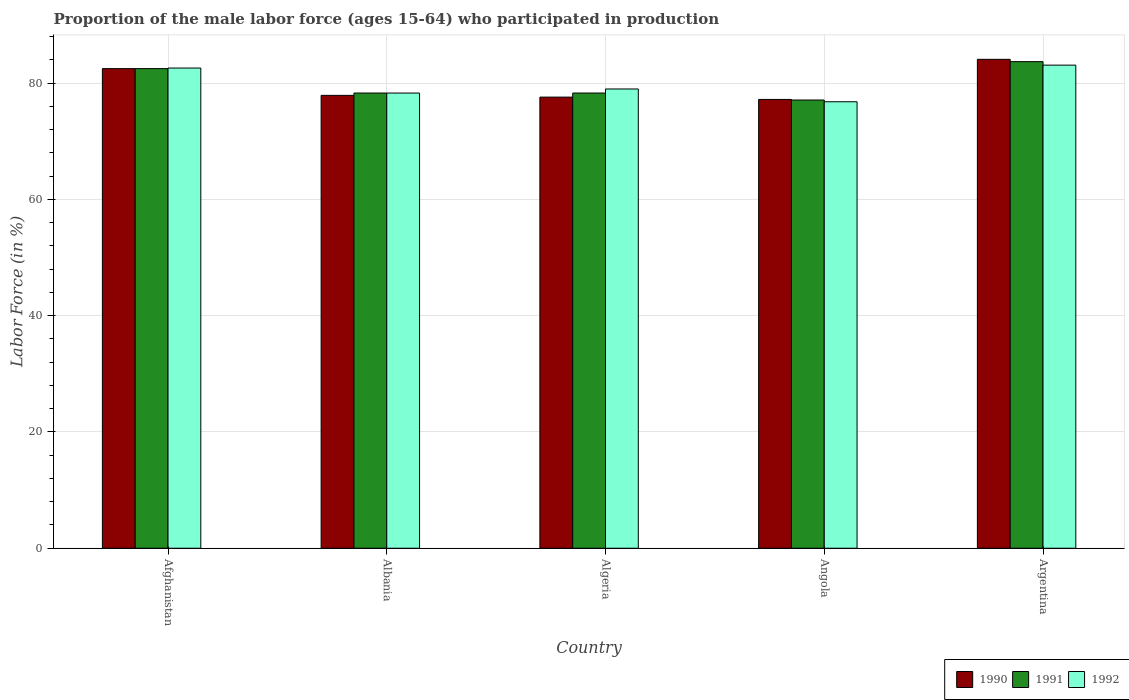How many different coloured bars are there?
Make the answer very short. 3. Are the number of bars per tick equal to the number of legend labels?
Provide a succinct answer. Yes. How many bars are there on the 5th tick from the left?
Your response must be concise. 3. What is the label of the 2nd group of bars from the left?
Provide a short and direct response. Albania. What is the proportion of the male labor force who participated in production in 1992 in Afghanistan?
Your response must be concise. 82.6. Across all countries, what is the maximum proportion of the male labor force who participated in production in 1991?
Offer a very short reply. 83.7. Across all countries, what is the minimum proportion of the male labor force who participated in production in 1990?
Offer a very short reply. 77.2. In which country was the proportion of the male labor force who participated in production in 1990 minimum?
Your response must be concise. Angola. What is the total proportion of the male labor force who participated in production in 1992 in the graph?
Provide a short and direct response. 399.8. What is the difference between the proportion of the male labor force who participated in production in 1991 in Angola and that in Argentina?
Keep it short and to the point. -6.6. What is the difference between the proportion of the male labor force who participated in production in 1990 in Argentina and the proportion of the male labor force who participated in production in 1992 in Afghanistan?
Your answer should be very brief. 1.5. What is the average proportion of the male labor force who participated in production in 1991 per country?
Provide a succinct answer. 79.98. What is the difference between the proportion of the male labor force who participated in production of/in 1992 and proportion of the male labor force who participated in production of/in 1991 in Algeria?
Make the answer very short. 0.7. In how many countries, is the proportion of the male labor force who participated in production in 1991 greater than 24 %?
Provide a succinct answer. 5. What is the ratio of the proportion of the male labor force who participated in production in 1990 in Algeria to that in Angola?
Make the answer very short. 1.01. Is the proportion of the male labor force who participated in production in 1991 in Afghanistan less than that in Angola?
Offer a very short reply. No. Is the difference between the proportion of the male labor force who participated in production in 1992 in Afghanistan and Albania greater than the difference between the proportion of the male labor force who participated in production in 1991 in Afghanistan and Albania?
Provide a short and direct response. Yes. What is the difference between the highest and the second highest proportion of the male labor force who participated in production in 1991?
Your answer should be compact. -1.2. What is the difference between the highest and the lowest proportion of the male labor force who participated in production in 1990?
Ensure brevity in your answer.  6.9. In how many countries, is the proportion of the male labor force who participated in production in 1992 greater than the average proportion of the male labor force who participated in production in 1992 taken over all countries?
Make the answer very short. 2. Is the sum of the proportion of the male labor force who participated in production in 1991 in Angola and Argentina greater than the maximum proportion of the male labor force who participated in production in 1990 across all countries?
Make the answer very short. Yes. What does the 2nd bar from the left in Albania represents?
Make the answer very short. 1991. What does the 1st bar from the right in Albania represents?
Provide a succinct answer. 1992. Is it the case that in every country, the sum of the proportion of the male labor force who participated in production in 1990 and proportion of the male labor force who participated in production in 1992 is greater than the proportion of the male labor force who participated in production in 1991?
Offer a terse response. Yes. How many bars are there?
Your response must be concise. 15. What is the difference between two consecutive major ticks on the Y-axis?
Keep it short and to the point. 20. Are the values on the major ticks of Y-axis written in scientific E-notation?
Your response must be concise. No. How many legend labels are there?
Keep it short and to the point. 3. How are the legend labels stacked?
Keep it short and to the point. Horizontal. What is the title of the graph?
Provide a short and direct response. Proportion of the male labor force (ages 15-64) who participated in production. Does "1968" appear as one of the legend labels in the graph?
Your answer should be compact. No. What is the label or title of the X-axis?
Offer a very short reply. Country. What is the label or title of the Y-axis?
Provide a short and direct response. Labor Force (in %). What is the Labor Force (in %) in 1990 in Afghanistan?
Offer a terse response. 82.5. What is the Labor Force (in %) of 1991 in Afghanistan?
Keep it short and to the point. 82.5. What is the Labor Force (in %) in 1992 in Afghanistan?
Keep it short and to the point. 82.6. What is the Labor Force (in %) of 1990 in Albania?
Give a very brief answer. 77.9. What is the Labor Force (in %) of 1991 in Albania?
Provide a succinct answer. 78.3. What is the Labor Force (in %) in 1992 in Albania?
Your answer should be compact. 78.3. What is the Labor Force (in %) of 1990 in Algeria?
Make the answer very short. 77.6. What is the Labor Force (in %) in 1991 in Algeria?
Offer a very short reply. 78.3. What is the Labor Force (in %) of 1992 in Algeria?
Your response must be concise. 79. What is the Labor Force (in %) of 1990 in Angola?
Keep it short and to the point. 77.2. What is the Labor Force (in %) of 1991 in Angola?
Your answer should be very brief. 77.1. What is the Labor Force (in %) of 1992 in Angola?
Keep it short and to the point. 76.8. What is the Labor Force (in %) in 1990 in Argentina?
Your answer should be very brief. 84.1. What is the Labor Force (in %) in 1991 in Argentina?
Provide a succinct answer. 83.7. What is the Labor Force (in %) in 1992 in Argentina?
Make the answer very short. 83.1. Across all countries, what is the maximum Labor Force (in %) in 1990?
Your response must be concise. 84.1. Across all countries, what is the maximum Labor Force (in %) in 1991?
Give a very brief answer. 83.7. Across all countries, what is the maximum Labor Force (in %) of 1992?
Provide a short and direct response. 83.1. Across all countries, what is the minimum Labor Force (in %) in 1990?
Make the answer very short. 77.2. Across all countries, what is the minimum Labor Force (in %) in 1991?
Your answer should be very brief. 77.1. Across all countries, what is the minimum Labor Force (in %) of 1992?
Keep it short and to the point. 76.8. What is the total Labor Force (in %) in 1990 in the graph?
Offer a terse response. 399.3. What is the total Labor Force (in %) of 1991 in the graph?
Make the answer very short. 399.9. What is the total Labor Force (in %) of 1992 in the graph?
Your response must be concise. 399.8. What is the difference between the Labor Force (in %) in 1990 in Afghanistan and that in Albania?
Offer a very short reply. 4.6. What is the difference between the Labor Force (in %) in 1991 in Afghanistan and that in Albania?
Provide a short and direct response. 4.2. What is the difference between the Labor Force (in %) in 1991 in Afghanistan and that in Algeria?
Give a very brief answer. 4.2. What is the difference between the Labor Force (in %) of 1992 in Afghanistan and that in Algeria?
Your answer should be compact. 3.6. What is the difference between the Labor Force (in %) in 1991 in Afghanistan and that in Argentina?
Make the answer very short. -1.2. What is the difference between the Labor Force (in %) in 1992 in Afghanistan and that in Argentina?
Offer a very short reply. -0.5. What is the difference between the Labor Force (in %) in 1991 in Albania and that in Algeria?
Ensure brevity in your answer.  0. What is the difference between the Labor Force (in %) of 1992 in Albania and that in Algeria?
Provide a succinct answer. -0.7. What is the difference between the Labor Force (in %) of 1990 in Albania and that in Angola?
Offer a very short reply. 0.7. What is the difference between the Labor Force (in %) in 1992 in Albania and that in Angola?
Offer a very short reply. 1.5. What is the difference between the Labor Force (in %) in 1991 in Albania and that in Argentina?
Make the answer very short. -5.4. What is the difference between the Labor Force (in %) of 1990 in Algeria and that in Angola?
Ensure brevity in your answer.  0.4. What is the difference between the Labor Force (in %) in 1990 in Algeria and that in Argentina?
Your answer should be very brief. -6.5. What is the difference between the Labor Force (in %) in 1991 in Angola and that in Argentina?
Your response must be concise. -6.6. What is the difference between the Labor Force (in %) in 1992 in Angola and that in Argentina?
Make the answer very short. -6.3. What is the difference between the Labor Force (in %) of 1990 in Afghanistan and the Labor Force (in %) of 1991 in Albania?
Offer a terse response. 4.2. What is the difference between the Labor Force (in %) of 1990 in Afghanistan and the Labor Force (in %) of 1991 in Algeria?
Offer a terse response. 4.2. What is the difference between the Labor Force (in %) in 1990 in Afghanistan and the Labor Force (in %) in 1992 in Algeria?
Provide a succinct answer. 3.5. What is the difference between the Labor Force (in %) of 1991 in Afghanistan and the Labor Force (in %) of 1992 in Algeria?
Your answer should be very brief. 3.5. What is the difference between the Labor Force (in %) of 1990 in Afghanistan and the Labor Force (in %) of 1991 in Angola?
Give a very brief answer. 5.4. What is the difference between the Labor Force (in %) in 1991 in Afghanistan and the Labor Force (in %) in 1992 in Angola?
Offer a very short reply. 5.7. What is the difference between the Labor Force (in %) of 1990 in Afghanistan and the Labor Force (in %) of 1992 in Argentina?
Offer a very short reply. -0.6. What is the difference between the Labor Force (in %) of 1991 in Afghanistan and the Labor Force (in %) of 1992 in Argentina?
Provide a succinct answer. -0.6. What is the difference between the Labor Force (in %) of 1991 in Albania and the Labor Force (in %) of 1992 in Algeria?
Your answer should be very brief. -0.7. What is the difference between the Labor Force (in %) in 1990 in Albania and the Labor Force (in %) in 1991 in Angola?
Offer a very short reply. 0.8. What is the difference between the Labor Force (in %) in 1990 in Albania and the Labor Force (in %) in 1992 in Angola?
Keep it short and to the point. 1.1. What is the difference between the Labor Force (in %) of 1991 in Albania and the Labor Force (in %) of 1992 in Argentina?
Provide a succinct answer. -4.8. What is the difference between the Labor Force (in %) in 1990 in Algeria and the Labor Force (in %) in 1992 in Angola?
Make the answer very short. 0.8. What is the difference between the Labor Force (in %) in 1990 in Algeria and the Labor Force (in %) in 1991 in Argentina?
Give a very brief answer. -6.1. What is the difference between the Labor Force (in %) of 1990 in Algeria and the Labor Force (in %) of 1992 in Argentina?
Make the answer very short. -5.5. What is the difference between the Labor Force (in %) in 1991 in Algeria and the Labor Force (in %) in 1992 in Argentina?
Your answer should be compact. -4.8. What is the average Labor Force (in %) in 1990 per country?
Your answer should be compact. 79.86. What is the average Labor Force (in %) in 1991 per country?
Give a very brief answer. 79.98. What is the average Labor Force (in %) in 1992 per country?
Give a very brief answer. 79.96. What is the difference between the Labor Force (in %) in 1990 and Labor Force (in %) in 1991 in Afghanistan?
Provide a short and direct response. 0. What is the difference between the Labor Force (in %) in 1990 and Labor Force (in %) in 1991 in Albania?
Make the answer very short. -0.4. What is the difference between the Labor Force (in %) of 1990 and Labor Force (in %) of 1992 in Albania?
Provide a short and direct response. -0.4. What is the difference between the Labor Force (in %) of 1990 and Labor Force (in %) of 1991 in Algeria?
Your answer should be very brief. -0.7. What is the difference between the Labor Force (in %) in 1991 and Labor Force (in %) in 1992 in Algeria?
Your response must be concise. -0.7. What is the difference between the Labor Force (in %) in 1990 and Labor Force (in %) in 1991 in Angola?
Make the answer very short. 0.1. What is the difference between the Labor Force (in %) in 1990 and Labor Force (in %) in 1992 in Angola?
Keep it short and to the point. 0.4. What is the difference between the Labor Force (in %) in 1990 and Labor Force (in %) in 1992 in Argentina?
Give a very brief answer. 1. What is the ratio of the Labor Force (in %) in 1990 in Afghanistan to that in Albania?
Your answer should be very brief. 1.06. What is the ratio of the Labor Force (in %) of 1991 in Afghanistan to that in Albania?
Ensure brevity in your answer.  1.05. What is the ratio of the Labor Force (in %) of 1992 in Afghanistan to that in Albania?
Your answer should be compact. 1.05. What is the ratio of the Labor Force (in %) of 1990 in Afghanistan to that in Algeria?
Provide a succinct answer. 1.06. What is the ratio of the Labor Force (in %) in 1991 in Afghanistan to that in Algeria?
Your response must be concise. 1.05. What is the ratio of the Labor Force (in %) in 1992 in Afghanistan to that in Algeria?
Provide a short and direct response. 1.05. What is the ratio of the Labor Force (in %) in 1990 in Afghanistan to that in Angola?
Keep it short and to the point. 1.07. What is the ratio of the Labor Force (in %) of 1991 in Afghanistan to that in Angola?
Provide a short and direct response. 1.07. What is the ratio of the Labor Force (in %) in 1992 in Afghanistan to that in Angola?
Keep it short and to the point. 1.08. What is the ratio of the Labor Force (in %) of 1990 in Afghanistan to that in Argentina?
Give a very brief answer. 0.98. What is the ratio of the Labor Force (in %) of 1991 in Afghanistan to that in Argentina?
Offer a very short reply. 0.99. What is the ratio of the Labor Force (in %) in 1990 in Albania to that in Algeria?
Provide a short and direct response. 1. What is the ratio of the Labor Force (in %) in 1992 in Albania to that in Algeria?
Keep it short and to the point. 0.99. What is the ratio of the Labor Force (in %) of 1990 in Albania to that in Angola?
Give a very brief answer. 1.01. What is the ratio of the Labor Force (in %) of 1991 in Albania to that in Angola?
Your response must be concise. 1.02. What is the ratio of the Labor Force (in %) in 1992 in Albania to that in Angola?
Make the answer very short. 1.02. What is the ratio of the Labor Force (in %) of 1990 in Albania to that in Argentina?
Keep it short and to the point. 0.93. What is the ratio of the Labor Force (in %) in 1991 in Albania to that in Argentina?
Offer a terse response. 0.94. What is the ratio of the Labor Force (in %) of 1992 in Albania to that in Argentina?
Make the answer very short. 0.94. What is the ratio of the Labor Force (in %) in 1990 in Algeria to that in Angola?
Your response must be concise. 1.01. What is the ratio of the Labor Force (in %) in 1991 in Algeria to that in Angola?
Keep it short and to the point. 1.02. What is the ratio of the Labor Force (in %) of 1992 in Algeria to that in Angola?
Offer a terse response. 1.03. What is the ratio of the Labor Force (in %) in 1990 in Algeria to that in Argentina?
Ensure brevity in your answer.  0.92. What is the ratio of the Labor Force (in %) of 1991 in Algeria to that in Argentina?
Offer a very short reply. 0.94. What is the ratio of the Labor Force (in %) in 1992 in Algeria to that in Argentina?
Make the answer very short. 0.95. What is the ratio of the Labor Force (in %) in 1990 in Angola to that in Argentina?
Your answer should be very brief. 0.92. What is the ratio of the Labor Force (in %) of 1991 in Angola to that in Argentina?
Give a very brief answer. 0.92. What is the ratio of the Labor Force (in %) of 1992 in Angola to that in Argentina?
Offer a terse response. 0.92. What is the difference between the highest and the second highest Labor Force (in %) of 1990?
Ensure brevity in your answer.  1.6. What is the difference between the highest and the lowest Labor Force (in %) in 1990?
Your response must be concise. 6.9. 